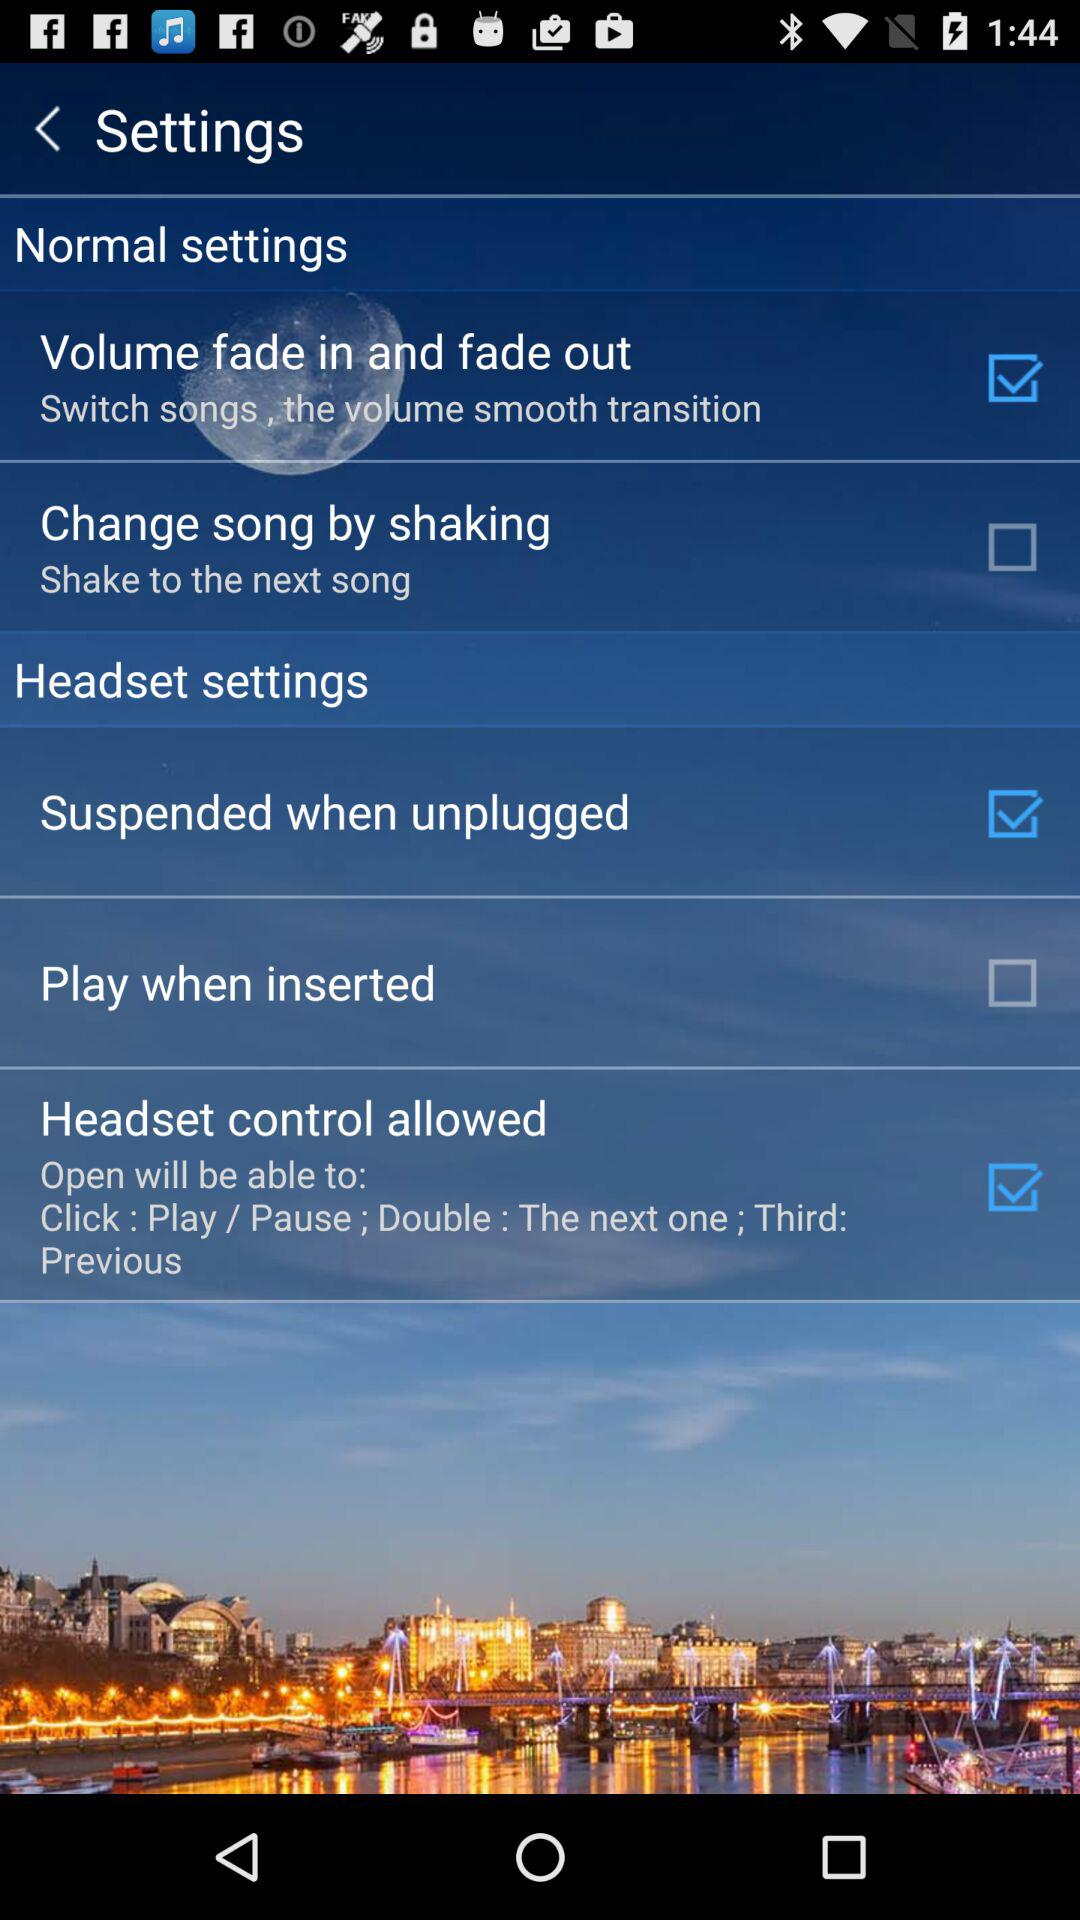How many headset settings are there?
Answer the question using a single word or phrase. 3 